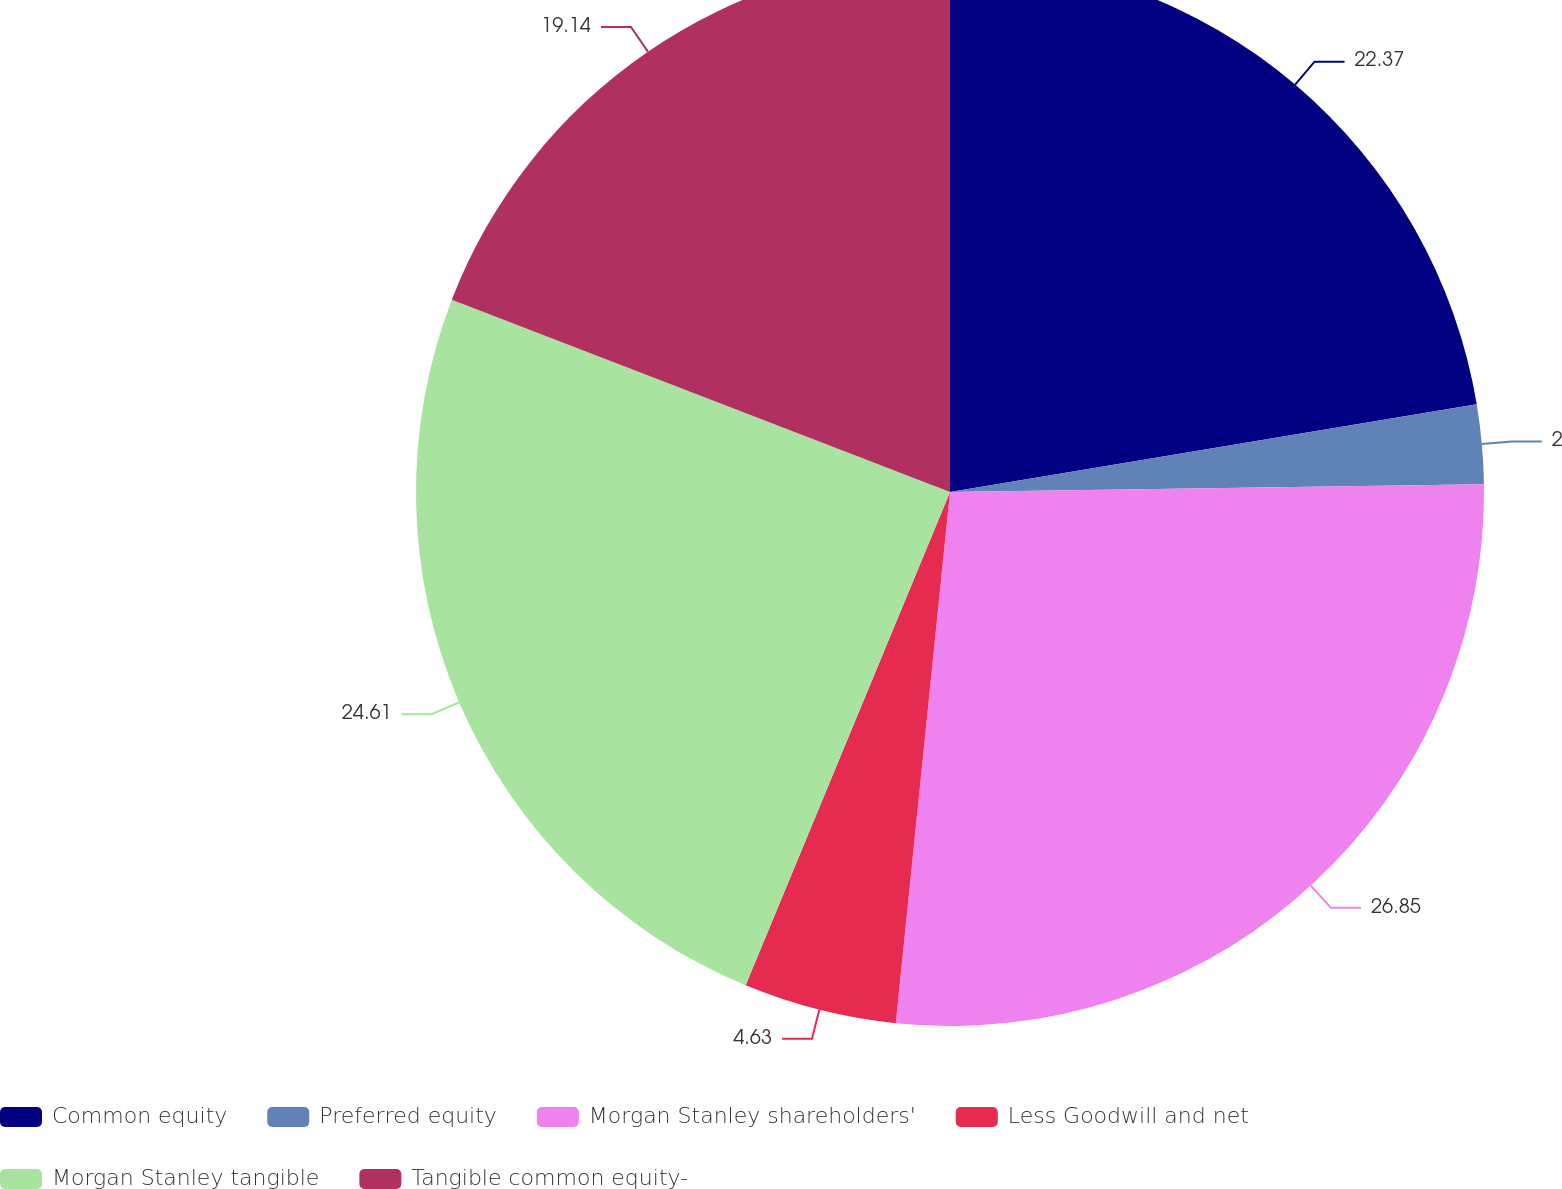<chart> <loc_0><loc_0><loc_500><loc_500><pie_chart><fcel>Common equity<fcel>Preferred equity<fcel>Morgan Stanley shareholders'<fcel>Less Goodwill and net<fcel>Morgan Stanley tangible<fcel>Tangible common equity-<nl><fcel>22.37%<fcel>2.4%<fcel>26.85%<fcel>4.63%<fcel>24.61%<fcel>19.14%<nl></chart> 